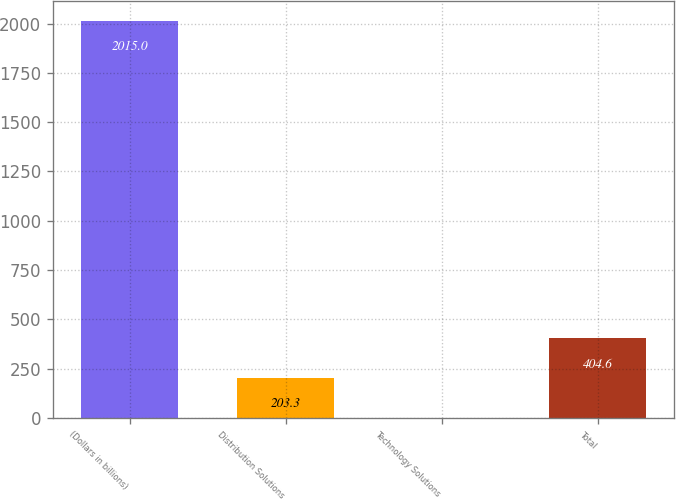Convert chart. <chart><loc_0><loc_0><loc_500><loc_500><bar_chart><fcel>(Dollars in billions)<fcel>Distribution Solutions<fcel>Technology Solutions<fcel>Total<nl><fcel>2015<fcel>203.3<fcel>2<fcel>404.6<nl></chart> 